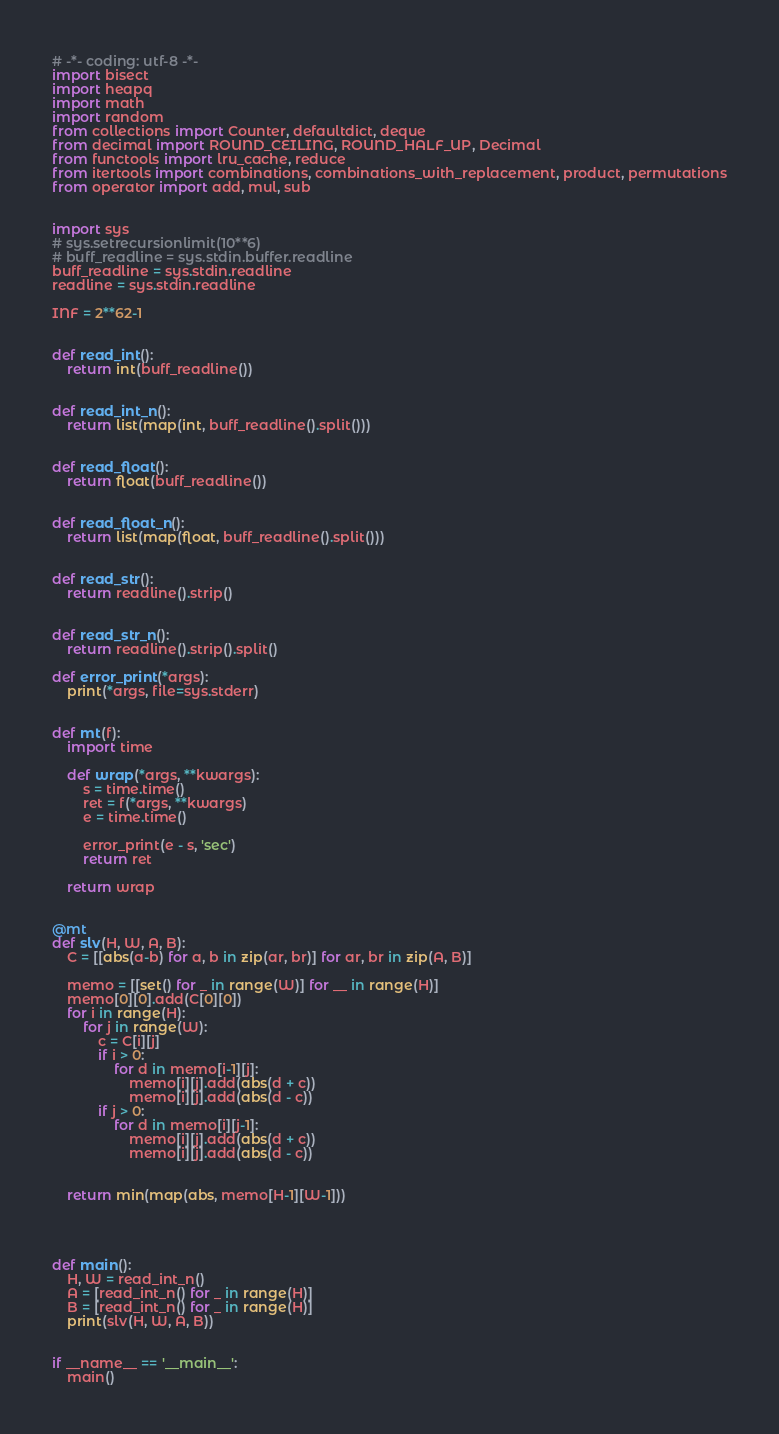<code> <loc_0><loc_0><loc_500><loc_500><_Python_># -*- coding: utf-8 -*-
import bisect
import heapq
import math
import random
from collections import Counter, defaultdict, deque
from decimal import ROUND_CEILING, ROUND_HALF_UP, Decimal
from functools import lru_cache, reduce
from itertools import combinations, combinations_with_replacement, product, permutations
from operator import add, mul, sub


import sys
# sys.setrecursionlimit(10**6)
# buff_readline = sys.stdin.buffer.readline
buff_readline = sys.stdin.readline
readline = sys.stdin.readline

INF = 2**62-1


def read_int():
    return int(buff_readline())


def read_int_n():
    return list(map(int, buff_readline().split()))


def read_float():
    return float(buff_readline())


def read_float_n():
    return list(map(float, buff_readline().split()))


def read_str():
    return readline().strip()


def read_str_n():
    return readline().strip().split()

def error_print(*args):
    print(*args, file=sys.stderr)


def mt(f):
    import time

    def wrap(*args, **kwargs):
        s = time.time()
        ret = f(*args, **kwargs)
        e = time.time()

        error_print(e - s, 'sec')
        return ret

    return wrap


@mt
def slv(H, W, A, B):
    C = [[abs(a-b) for a, b in zip(ar, br)] for ar, br in zip(A, B)]

    memo = [[set() for _ in range(W)] for __ in range(H)]
    memo[0][0].add(C[0][0])
    for i in range(H):
        for j in range(W):
            c = C[i][j]
            if i > 0:
                for d in memo[i-1][j]:
                    memo[i][j].add(abs(d + c))
                    memo[i][j].add(abs(d - c))
            if j > 0:
                for d in memo[i][j-1]:
                    memo[i][j].add(abs(d + c))
                    memo[i][j].add(abs(d - c))


    return min(map(abs, memo[H-1][W-1]))




def main():
    H, W = read_int_n()
    A = [read_int_n() for _ in range(H)]
    B = [read_int_n() for _ in range(H)]
    print(slv(H, W, A, B))


if __name__ == '__main__':
    main()
</code> 